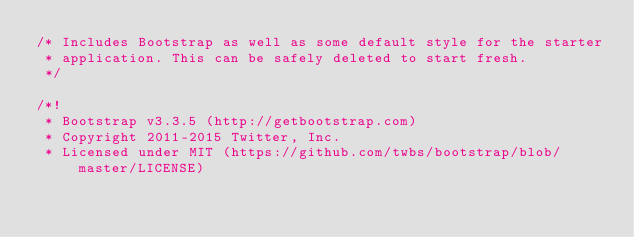Convert code to text. <code><loc_0><loc_0><loc_500><loc_500><_CSS_>/* Includes Bootstrap as well as some default style for the starter
 * application. This can be safely deleted to start fresh.
 */

/*!
 * Bootstrap v3.3.5 (http://getbootstrap.com)
 * Copyright 2011-2015 Twitter, Inc.
 * Licensed under MIT (https://github.com/twbs/bootstrap/blob/master/LICENSE)</code> 